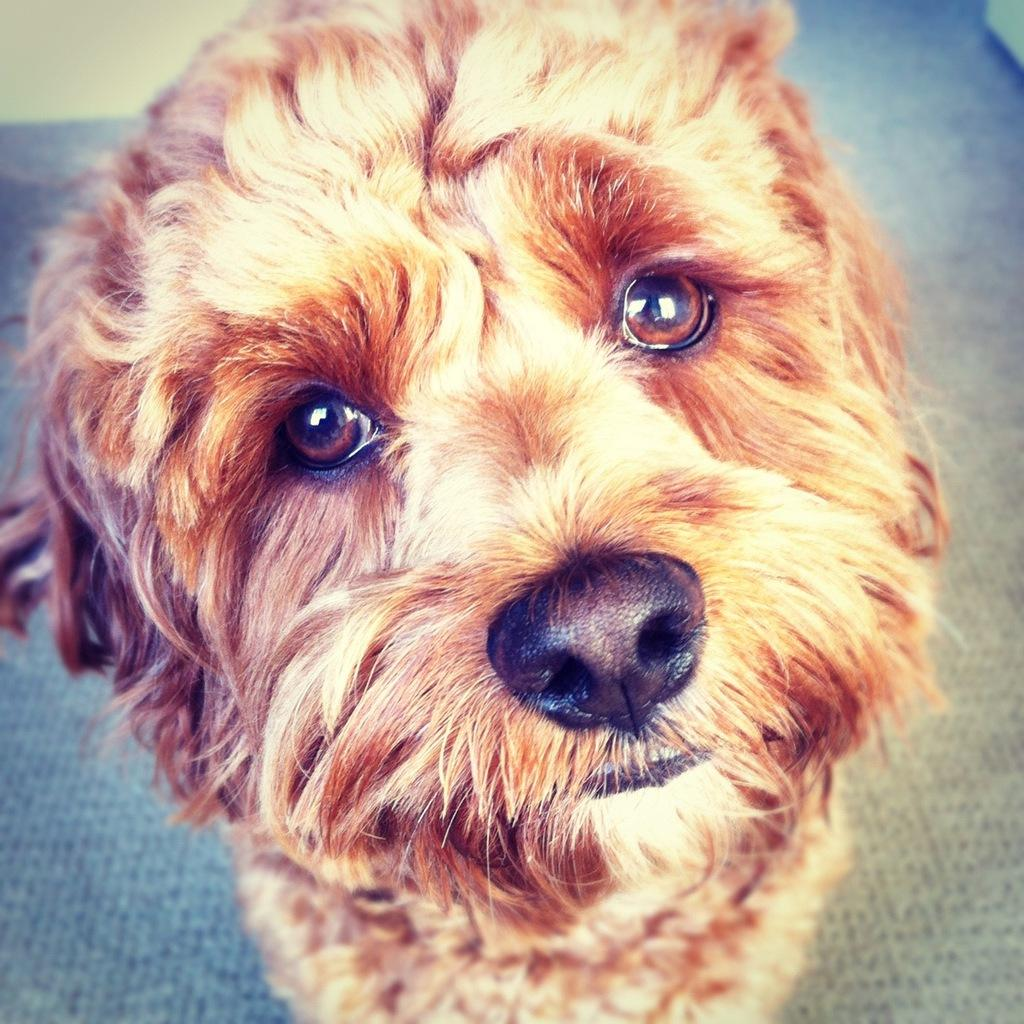What type of animal is in the picture? There is a dog in the picture. What is located at the bottom of the picture? There is a mat at the bottom of the picture. Where is the crow performing on the stage in the image? There is no crow or stage present in the image; it only features a dog and a mat. 